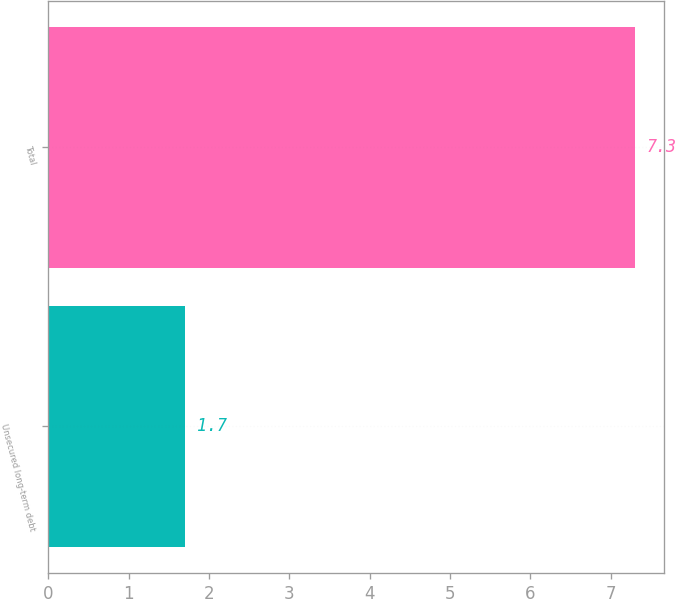Convert chart. <chart><loc_0><loc_0><loc_500><loc_500><bar_chart><fcel>Unsecured long-term debt<fcel>Total<nl><fcel>1.7<fcel>7.3<nl></chart> 